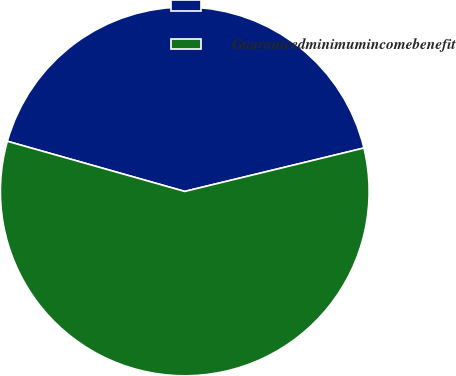Convert chart to OTSL. <chart><loc_0><loc_0><loc_500><loc_500><pie_chart><ecel><fcel>Guaranteedminimumincomebenefit<nl><fcel>41.83%<fcel>58.17%<nl></chart> 